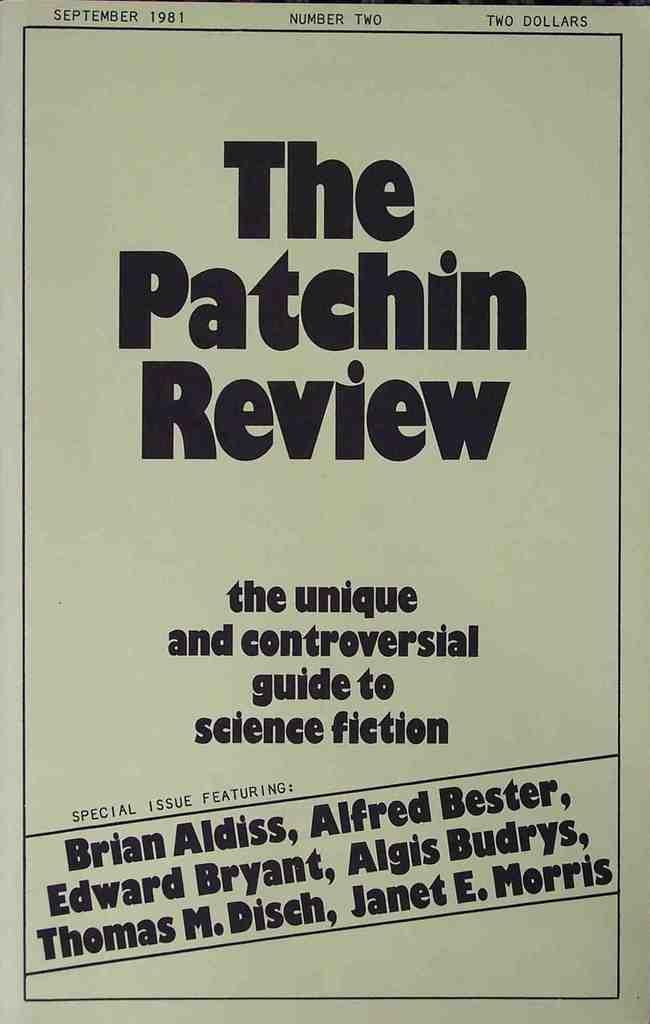Provide a one-sentence caption for the provided image. A poster advertising a 'unique and controversial guide to science fiction.'. 